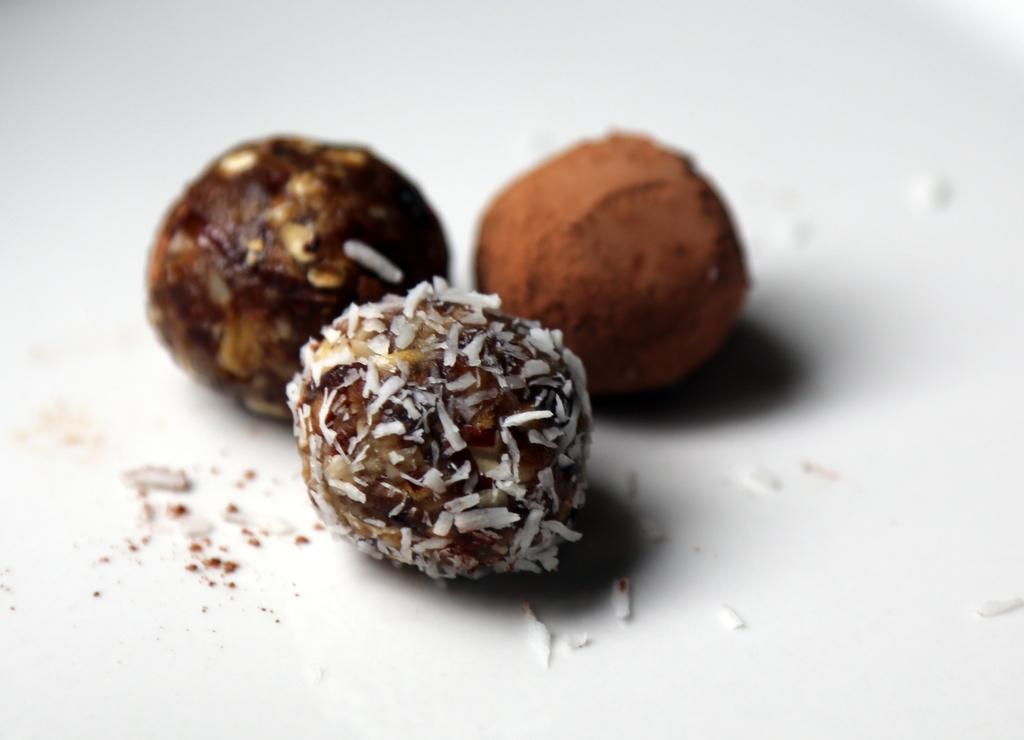What is present in the image? There is food in the image. What is the food placed on? The food is on a white object. What company is responsible for organizing the trip in the image? There is no trip or company present in the image; it only features food on a white object. 